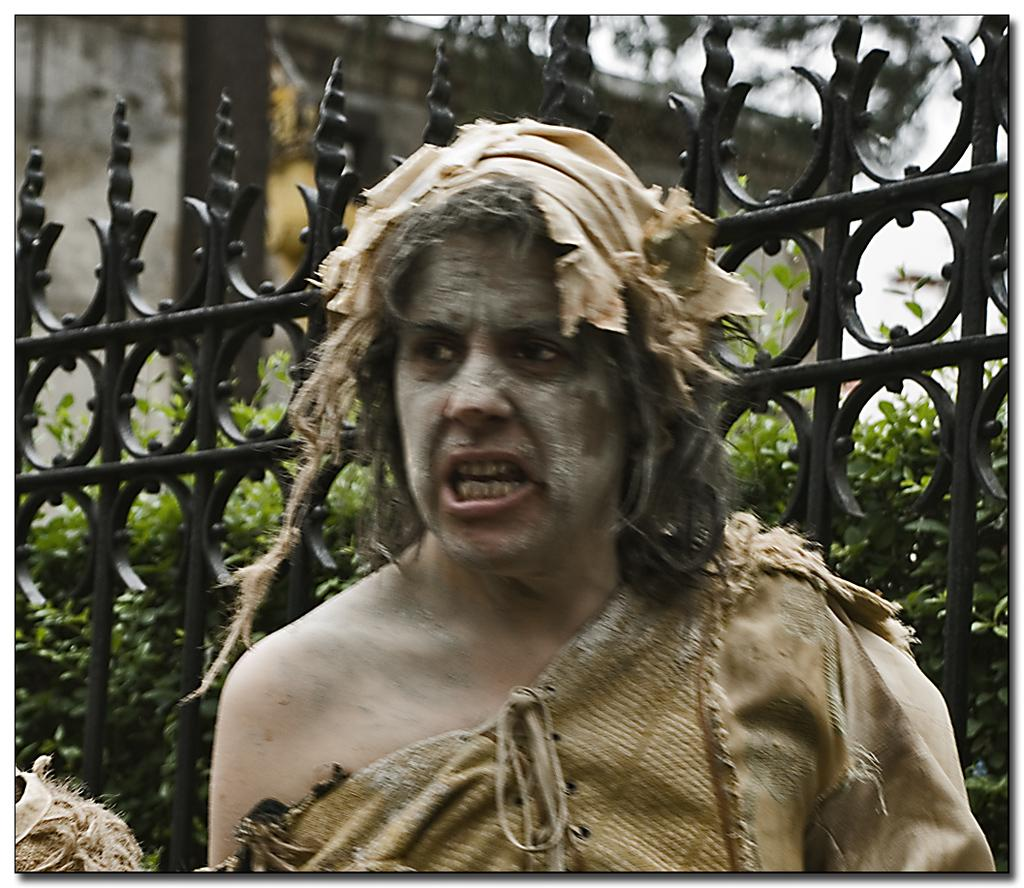What is the main subject of the image? There is a person in the image. What is on the person's face? Mud is on the person's face. What can be seen behind the person? There is a grille in the image, and plants are visible through it. How would you describe the background of the image? The background of the image is blurry. What type of breakfast is the person eating in the image? There is no indication of breakfast in the image; the person's face is covered in mud. How does the person's stomach feel after eating the pear in the image? There is no pear or mention of eating in the image; the person's face is covered in mud. 